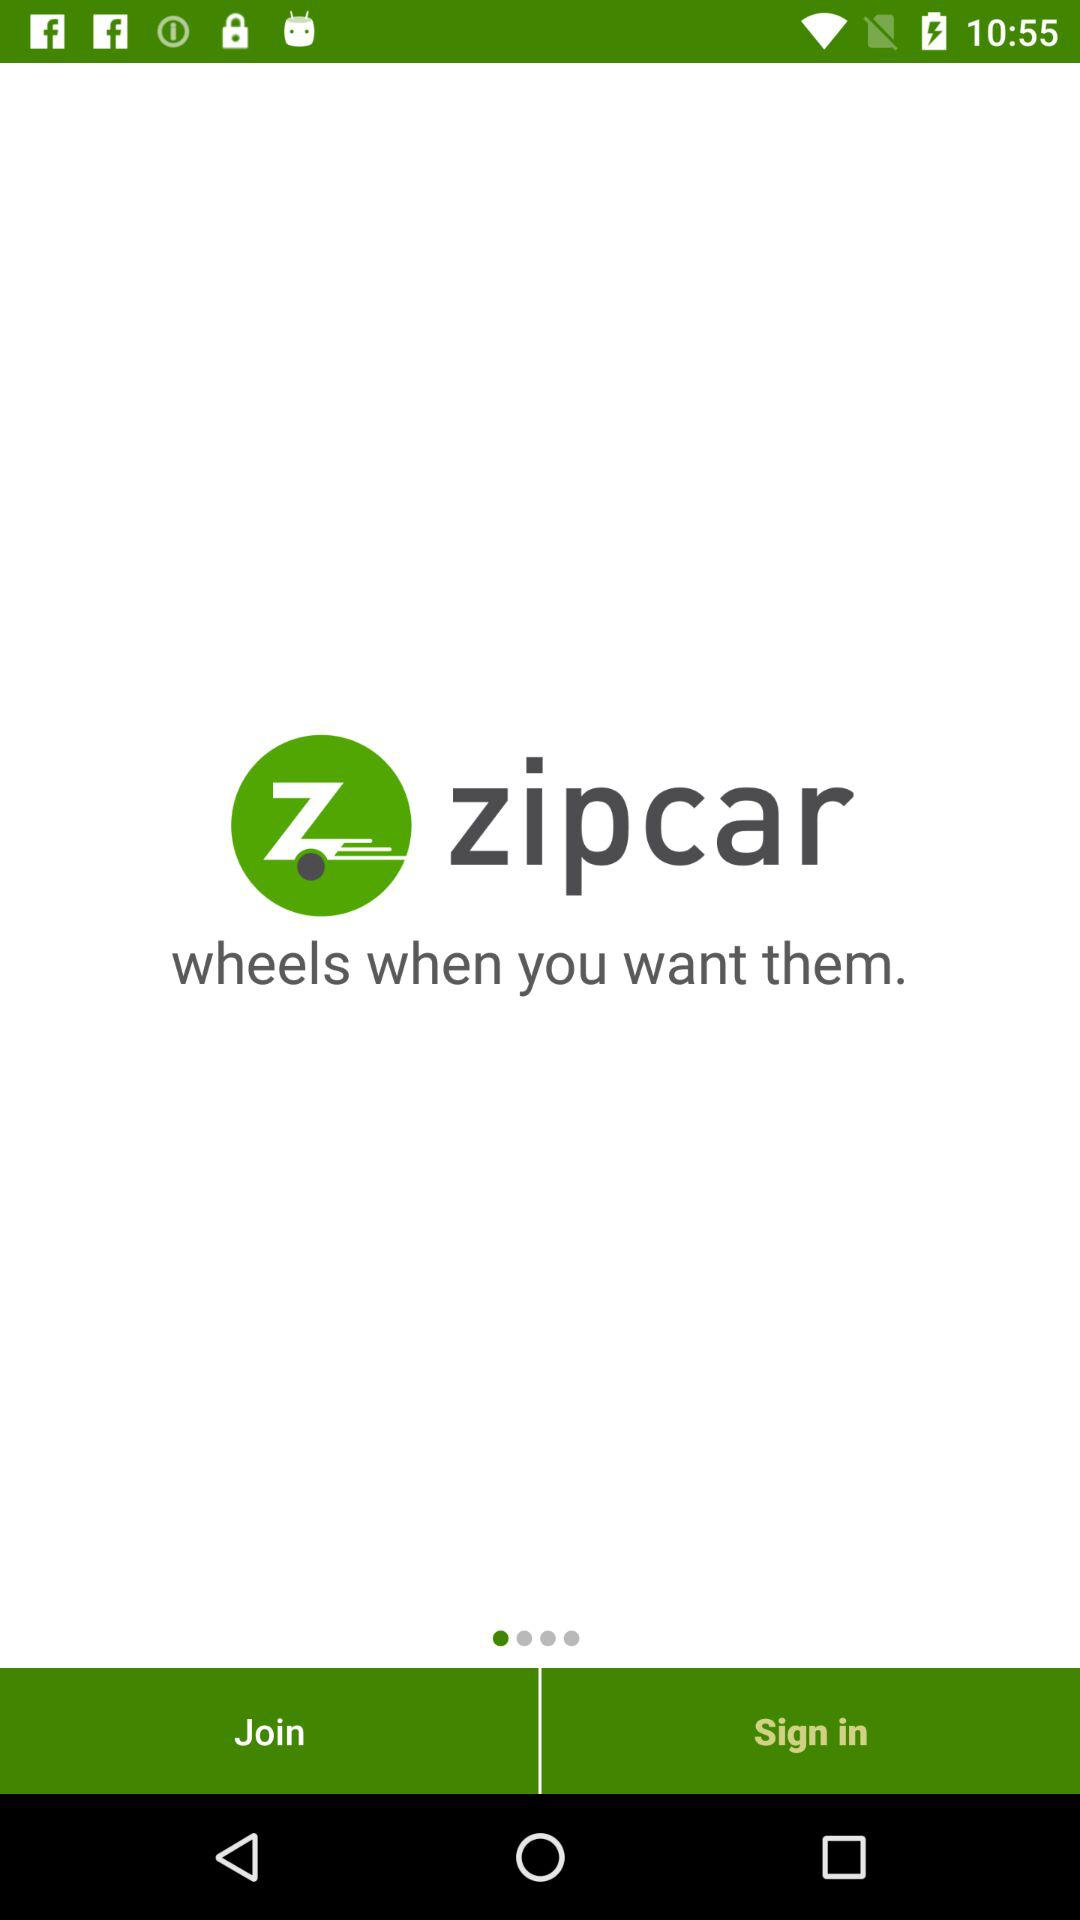What is the name of the application? The application name is Zipcar. 